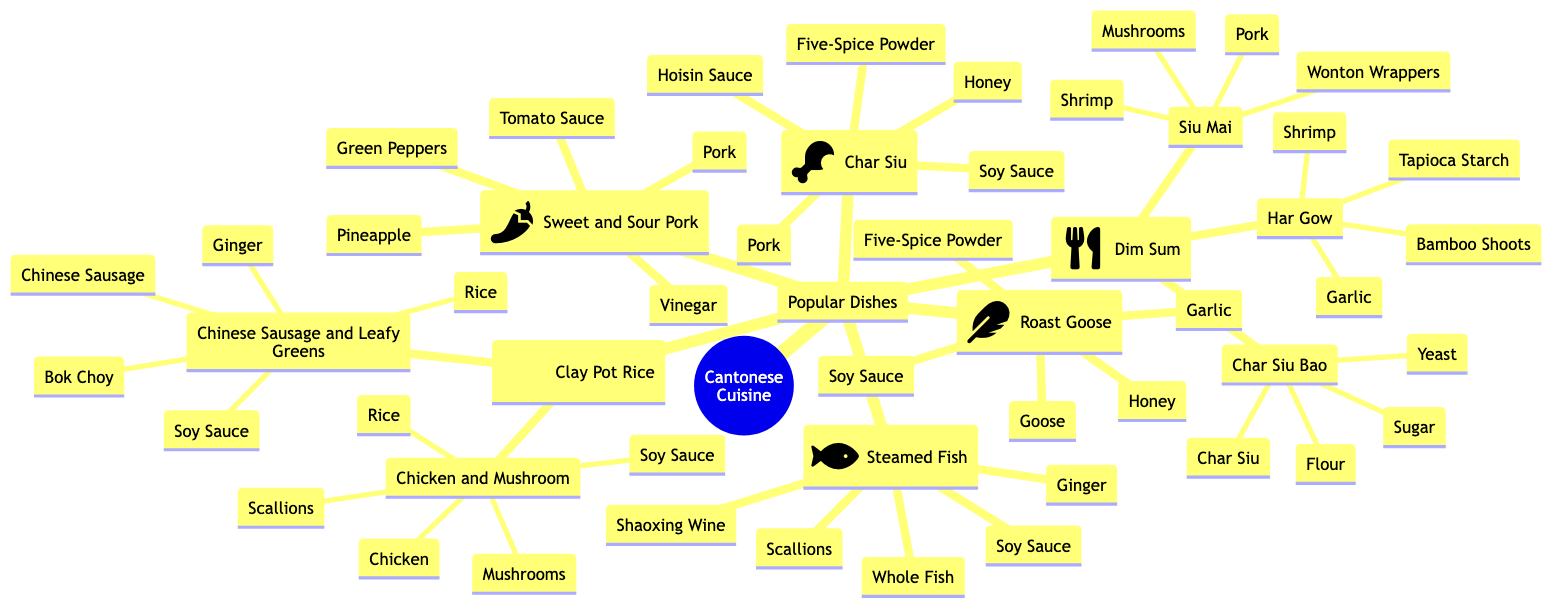what are the main categories of Cantonese cuisine? The main categories of Cantonese cuisine in the diagram are listed under "Popular Dishes." They include Char Siu, Dim Sum, Sweet and Sour Pork, Steamed Fish with Ginger and Scallions, Roast Goose, and Clay Pot Rice.
Answer: Popular Dishes how many ingredients are listed for Sweet and Sour Pork? The ingredients for Sweet and Sour Pork are Pork, Pineapple, Green Peppers, Vinegar, and Tomato Sauce. Counting these, there are five ingredients in total.
Answer: 5 which dish contains shrimp as an ingredient? Looking at the popular dishes and their ingredients, Har Gow (Shrimp Dumplings) and Siu Mai (Pork Dumplings) both include shrimp among their ingredients.
Answer: Har Gow, Siu Mai what is the primary ingredient in Char Siu? Char Siu primarily consists of pork, as indicated in the "Ingredients" section under Char Siu.
Answer: Pork which dish has yeast as one of its ingredients? Char Siu Bao (BBQ Pork Buns) is the dish that includes yeast as one of its ingredients, as shown in the list under Dim Sum.
Answer: Char Siu Bao how many popular varieties of Dim Sum are outlined in the diagram? Under the Dim Sum category, there are three popular varieties listed: Har Gow, Siu Mai, and Char Siu Bao. Counting these, we find there are three varieties.
Answer: 3 what ingredient is common in both Roast Goose and Char Siu? The common ingredient in both Roast Goose and Char Siu is soy sauce, which appears in the ingredients list for both dishes.
Answer: Soy Sauce which dish features ginger in its ingredients? The dish that features ginger in its ingredients is Steamed Fish with Ginger and Scallions, as indicated in the section for that dish.
Answer: Steamed Fish with Ginger and Scallions what is the unique ingredient in Clay Pot Rice - Chicken and Mushroom? The unique ingredient in the Clay Pot Rice - Chicken and Mushroom is chicken, which is specifically mentioned in the ingredients for that dish.
Answer: Chicken 